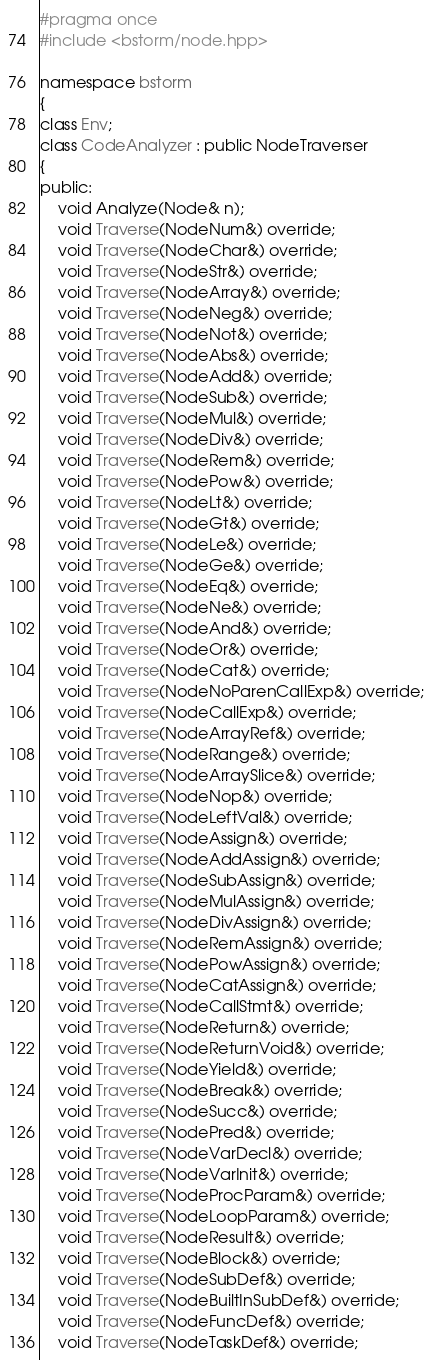<code> <loc_0><loc_0><loc_500><loc_500><_C++_>#pragma once
#include <bstorm/node.hpp>

namespace bstorm
{
class Env;
class CodeAnalyzer : public NodeTraverser
{
public:
    void Analyze(Node& n);
    void Traverse(NodeNum&) override;
    void Traverse(NodeChar&) override;
    void Traverse(NodeStr&) override;
    void Traverse(NodeArray&) override;
    void Traverse(NodeNeg&) override;
    void Traverse(NodeNot&) override;
    void Traverse(NodeAbs&) override;
    void Traverse(NodeAdd&) override;
    void Traverse(NodeSub&) override;
    void Traverse(NodeMul&) override;
    void Traverse(NodeDiv&) override;
    void Traverse(NodeRem&) override;
    void Traverse(NodePow&) override;
    void Traverse(NodeLt&) override;
    void Traverse(NodeGt&) override;
    void Traverse(NodeLe&) override;
    void Traverse(NodeGe&) override;
    void Traverse(NodeEq&) override;
    void Traverse(NodeNe&) override;
    void Traverse(NodeAnd&) override;
    void Traverse(NodeOr&) override;
    void Traverse(NodeCat&) override;
    void Traverse(NodeNoParenCallExp&) override;
    void Traverse(NodeCallExp&) override;
    void Traverse(NodeArrayRef&) override;
    void Traverse(NodeRange&) override;
    void Traverse(NodeArraySlice&) override;
    void Traverse(NodeNop&) override;
    void Traverse(NodeLeftVal&) override;
    void Traverse(NodeAssign&) override;
    void Traverse(NodeAddAssign&) override;
    void Traverse(NodeSubAssign&) override;
    void Traverse(NodeMulAssign&) override;
    void Traverse(NodeDivAssign&) override;
    void Traverse(NodeRemAssign&) override;
    void Traverse(NodePowAssign&) override;
    void Traverse(NodeCatAssign&) override;
    void Traverse(NodeCallStmt&) override;
    void Traverse(NodeReturn&) override;
    void Traverse(NodeReturnVoid&) override;
    void Traverse(NodeYield&) override;
    void Traverse(NodeBreak&) override;
    void Traverse(NodeSucc&) override;
    void Traverse(NodePred&) override;
    void Traverse(NodeVarDecl&) override;
    void Traverse(NodeVarInit&) override;
    void Traverse(NodeProcParam&) override;
    void Traverse(NodeLoopParam&) override;
    void Traverse(NodeResult&) override;
    void Traverse(NodeBlock&) override;
    void Traverse(NodeSubDef&) override;
    void Traverse(NodeBuiltInSubDef&) override;
    void Traverse(NodeFuncDef&) override;
    void Traverse(NodeTaskDef&) override;</code> 